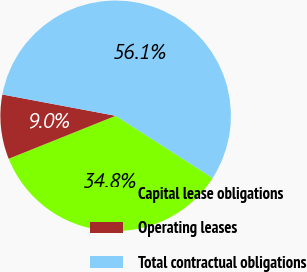Convert chart. <chart><loc_0><loc_0><loc_500><loc_500><pie_chart><fcel>Capital lease obligations<fcel>Operating leases<fcel>Total contractual obligations<nl><fcel>34.84%<fcel>9.04%<fcel>56.12%<nl></chart> 